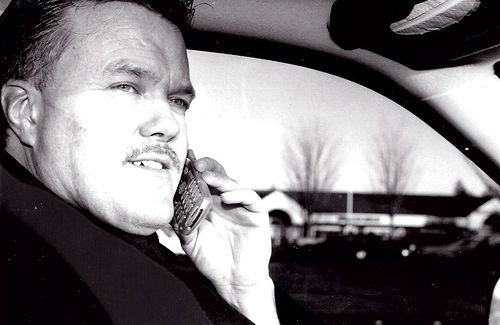Describe the objects in this image and their specific colors. I can see people in gray, black, white, and darkgray tones, cell phone in gray, darkgray, black, and lightgray tones, and car in gray and black tones in this image. 